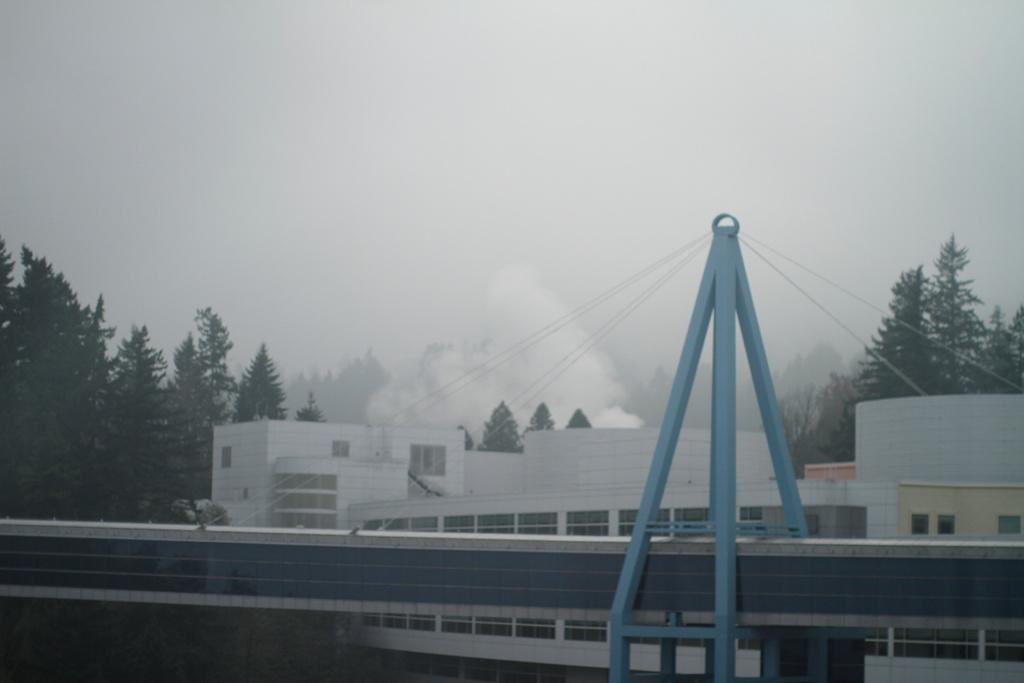What is the main structure visible in the image? There is a wall in the image. What is connected to the wall? The wall is connected to wires. What else is connected to the wires? Metal rods are connected to the wires. What can be seen in the background of the image? There is a building and trees in the background of the image. What is visible at the top of the image? The sky is visible at the top of the image. Can you see the ice on the wall in the image? There is no ice present on the wall in the image. What type of animal can be seen interacting with the metal rods in the image? There are no animals present in the image; it only features a wall, wires, and metal rods. 